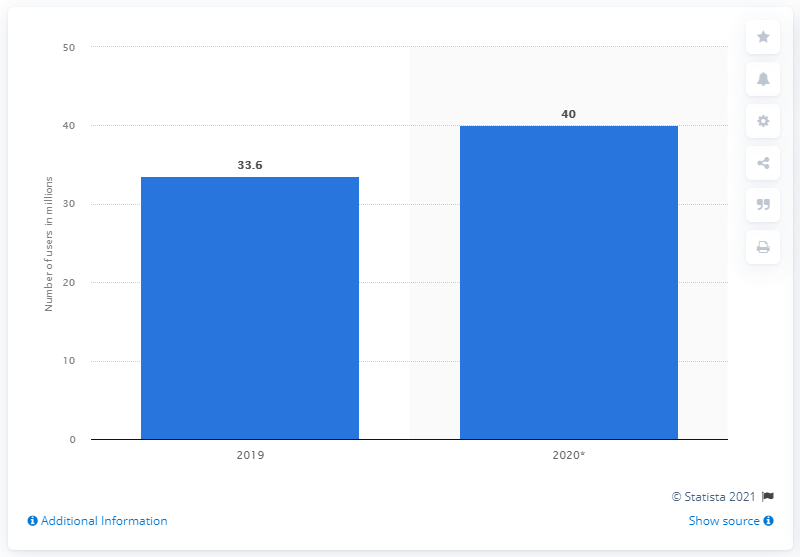Mention a couple of crucial points in this snapshot. The estimated number of Apple TV Plus users by 2020 is projected to be around 40 million. At the end of 2019, the number of Apple TV Plus users was approximately 33.6 million. 